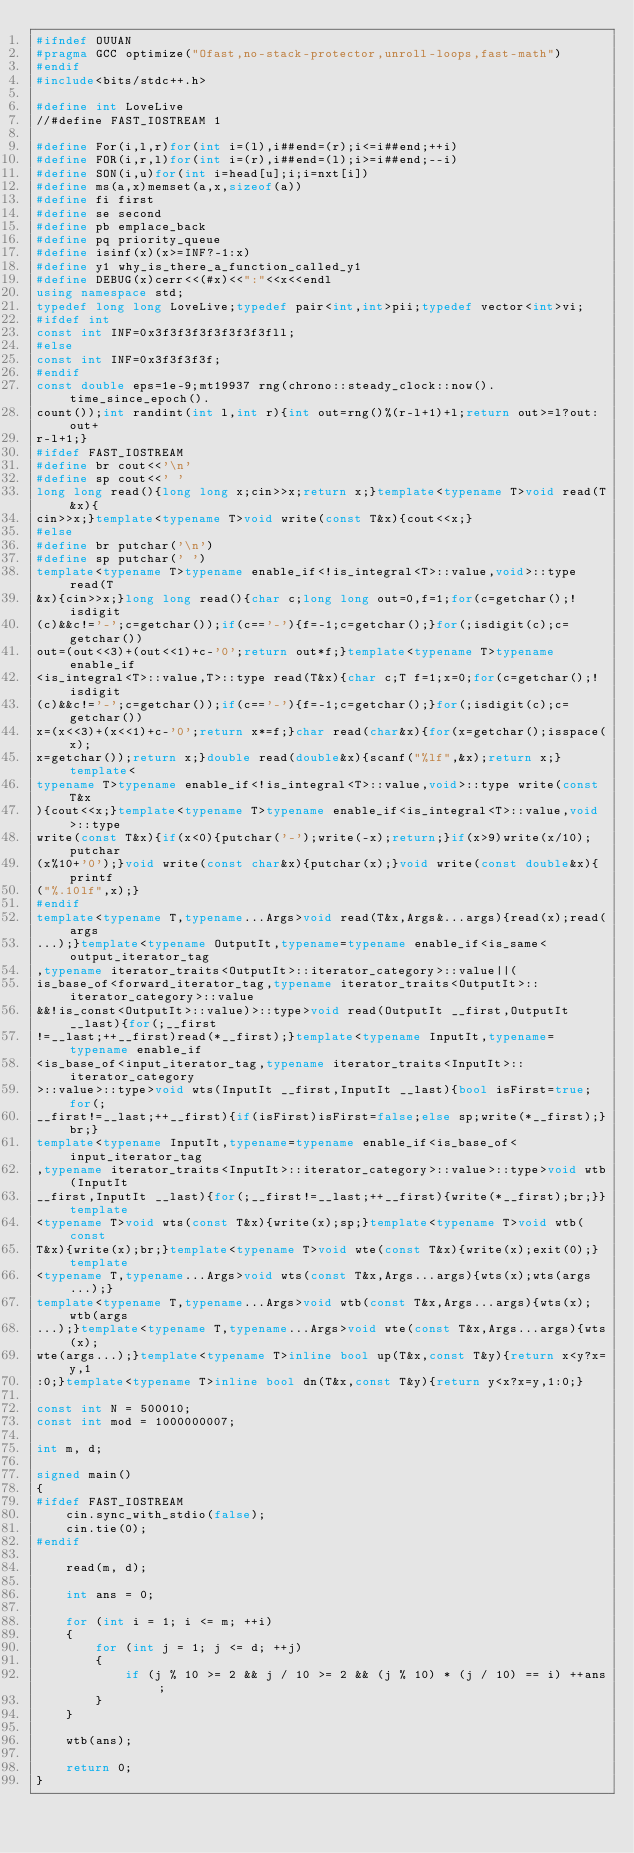Convert code to text. <code><loc_0><loc_0><loc_500><loc_500><_C++_>#ifndef OUUAN
#pragma GCC optimize("Ofast,no-stack-protector,unroll-loops,fast-math")
#endif
#include<bits/stdc++.h>

#define int LoveLive
//#define FAST_IOSTREAM 1

#define For(i,l,r)for(int i=(l),i##end=(r);i<=i##end;++i)
#define FOR(i,r,l)for(int i=(r),i##end=(l);i>=i##end;--i)
#define SON(i,u)for(int i=head[u];i;i=nxt[i])
#define ms(a,x)memset(a,x,sizeof(a))
#define fi first
#define se second
#define pb emplace_back
#define pq priority_queue
#define isinf(x)(x>=INF?-1:x)
#define y1 why_is_there_a_function_called_y1
#define DEBUG(x)cerr<<(#x)<<":"<<x<<endl
using namespace std;
typedef long long LoveLive;typedef pair<int,int>pii;typedef vector<int>vi;
#ifdef int
const int INF=0x3f3f3f3f3f3f3f3fll;
#else
const int INF=0x3f3f3f3f;
#endif
const double eps=1e-9;mt19937 rng(chrono::steady_clock::now().time_since_epoch().
count());int randint(int l,int r){int out=rng()%(r-l+1)+l;return out>=l?out:out+
r-l+1;}
#ifdef FAST_IOSTREAM
#define br cout<<'\n'
#define sp cout<<' '
long long read(){long long x;cin>>x;return x;}template<typename T>void read(T&x){
cin>>x;}template<typename T>void write(const T&x){cout<<x;}
#else
#define br putchar('\n')
#define sp putchar(' ')
template<typename T>typename enable_if<!is_integral<T>::value,void>::type read(T
&x){cin>>x;}long long read(){char c;long long out=0,f=1;for(c=getchar();!isdigit
(c)&&c!='-';c=getchar());if(c=='-'){f=-1;c=getchar();}for(;isdigit(c);c=getchar())
out=(out<<3)+(out<<1)+c-'0';return out*f;}template<typename T>typename enable_if
<is_integral<T>::value,T>::type read(T&x){char c;T f=1;x=0;for(c=getchar();!isdigit
(c)&&c!='-';c=getchar());if(c=='-'){f=-1;c=getchar();}for(;isdigit(c);c=getchar())
x=(x<<3)+(x<<1)+c-'0';return x*=f;}char read(char&x){for(x=getchar();isspace(x);
x=getchar());return x;}double read(double&x){scanf("%lf",&x);return x;}template<
typename T>typename enable_if<!is_integral<T>::value,void>::type write(const T&x
){cout<<x;}template<typename T>typename enable_if<is_integral<T>::value,void>::type
write(const T&x){if(x<0){putchar('-');write(-x);return;}if(x>9)write(x/10);putchar
(x%10+'0');}void write(const char&x){putchar(x);}void write(const double&x){printf
("%.10lf",x);}
#endif
template<typename T,typename...Args>void read(T&x,Args&...args){read(x);read(args
...);}template<typename OutputIt,typename=typename enable_if<is_same<output_iterator_tag
,typename iterator_traits<OutputIt>::iterator_category>::value||(
is_base_of<forward_iterator_tag,typename iterator_traits<OutputIt>::iterator_category>::value
&&!is_const<OutputIt>::value)>::type>void read(OutputIt __first,OutputIt __last){for(;__first
!=__last;++__first)read(*__first);}template<typename InputIt,typename=typename enable_if
<is_base_of<input_iterator_tag,typename iterator_traits<InputIt>::iterator_category
>::value>::type>void wts(InputIt __first,InputIt __last){bool isFirst=true;for(;
__first!=__last;++__first){if(isFirst)isFirst=false;else sp;write(*__first);}br;}
template<typename InputIt,typename=typename enable_if<is_base_of<input_iterator_tag
,typename iterator_traits<InputIt>::iterator_category>::value>::type>void wtb(InputIt
__first,InputIt __last){for(;__first!=__last;++__first){write(*__first);br;}}template
<typename T>void wts(const T&x){write(x);sp;}template<typename T>void wtb(const
T&x){write(x);br;}template<typename T>void wte(const T&x){write(x);exit(0);}template
<typename T,typename...Args>void wts(const T&x,Args...args){wts(x);wts(args...);}
template<typename T,typename...Args>void wtb(const T&x,Args...args){wts(x);wtb(args
...);}template<typename T,typename...Args>void wte(const T&x,Args...args){wts(x);
wte(args...);}template<typename T>inline bool up(T&x,const T&y){return x<y?x=y,1
:0;}template<typename T>inline bool dn(T&x,const T&y){return y<x?x=y,1:0;}

const int N = 500010;
const int mod = 1000000007;

int m, d;

signed main()
{
#ifdef FAST_IOSTREAM
	cin.sync_with_stdio(false);
	cin.tie(0);
#endif
	
	read(m, d);
	
	int ans = 0;
	
	for (int i = 1; i <= m; ++i)
	{
		for (int j = 1; j <= d; ++j)
		{
			if (j % 10 >= 2 && j / 10 >= 2 && (j % 10) * (j / 10) == i) ++ans;
		}
	}
	
	wtb(ans);
	
	return 0;
}</code> 